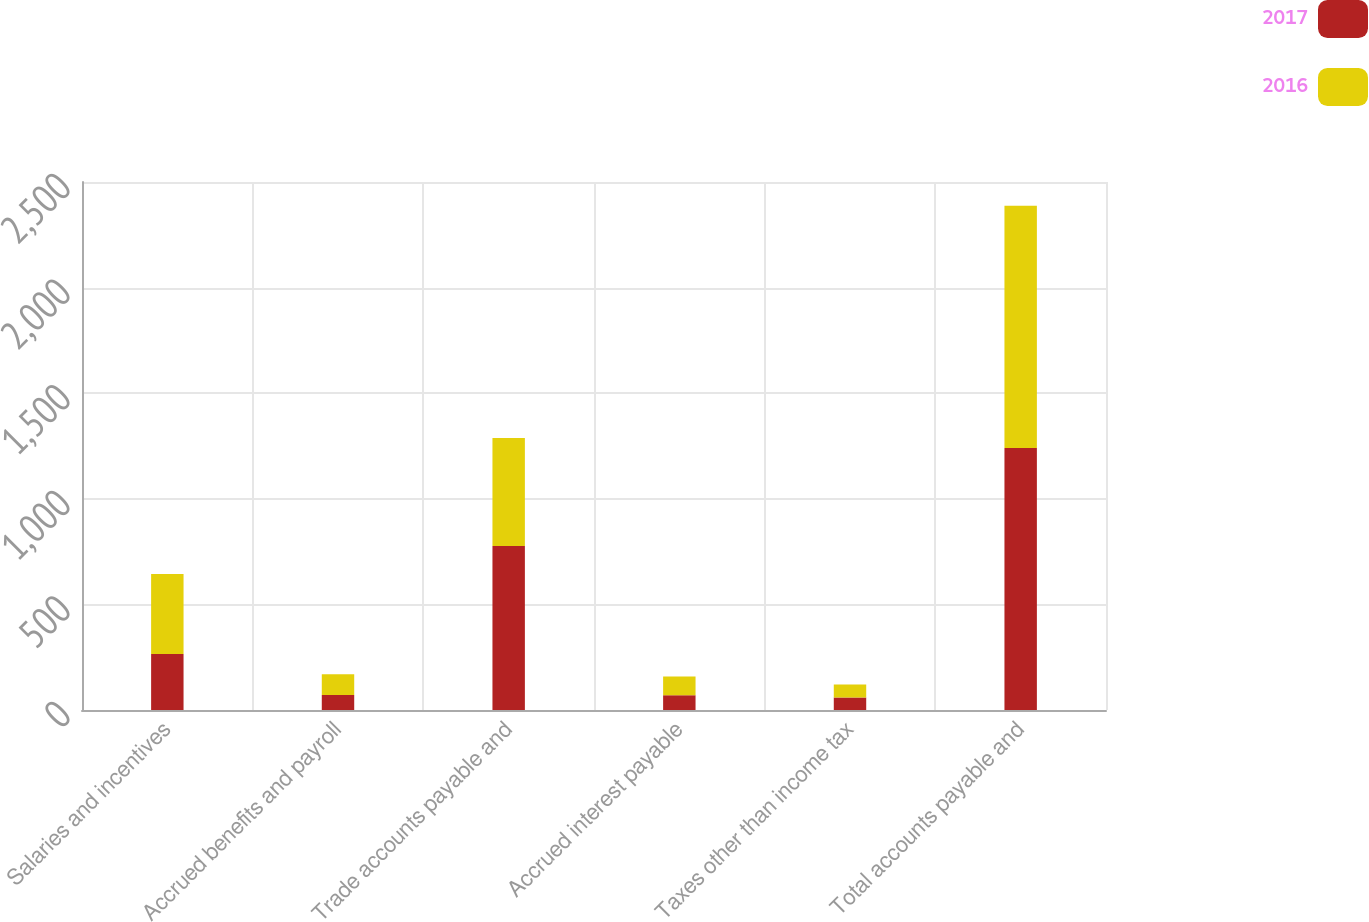Convert chart. <chart><loc_0><loc_0><loc_500><loc_500><stacked_bar_chart><ecel><fcel>Salaries and incentives<fcel>Accrued benefits and payroll<fcel>Trade accounts payable and<fcel>Accrued interest payable<fcel>Taxes other than income tax<fcel>Total accounts payable and<nl><fcel>2017<fcel>265<fcel>71<fcel>776<fcel>70<fcel>59<fcel>1241<nl><fcel>2016<fcel>379<fcel>98<fcel>512<fcel>89<fcel>62<fcel>1146<nl></chart> 